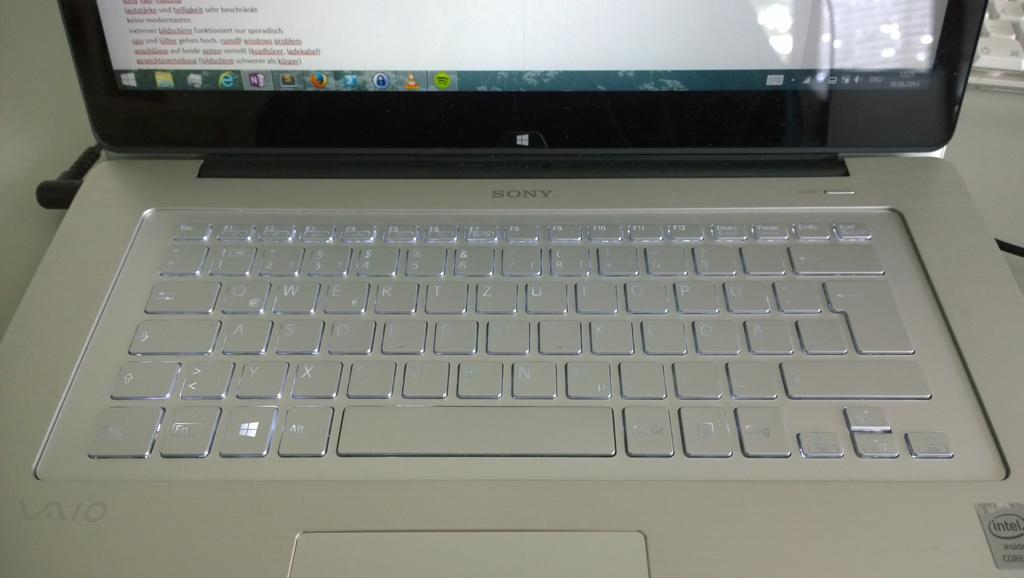What electronic device is present in the image? There is a laptop in the image. What feature of the laptop is visible in the image? The laptop has visible key buttons. What can be seen on the laptop screen? There is text visible on the laptop screen. What type of disgusting food is being displayed on the laptop screen? There is no food, disgusting or otherwise, displayed on the laptop screen; it shows text. What type of shade is being used to cover the laptop? There is no shade present in the image; the laptop is not covered. What type of lace decoration is present on the laptop? There is no lace decoration present on the laptop; it is a standard electronic device. 